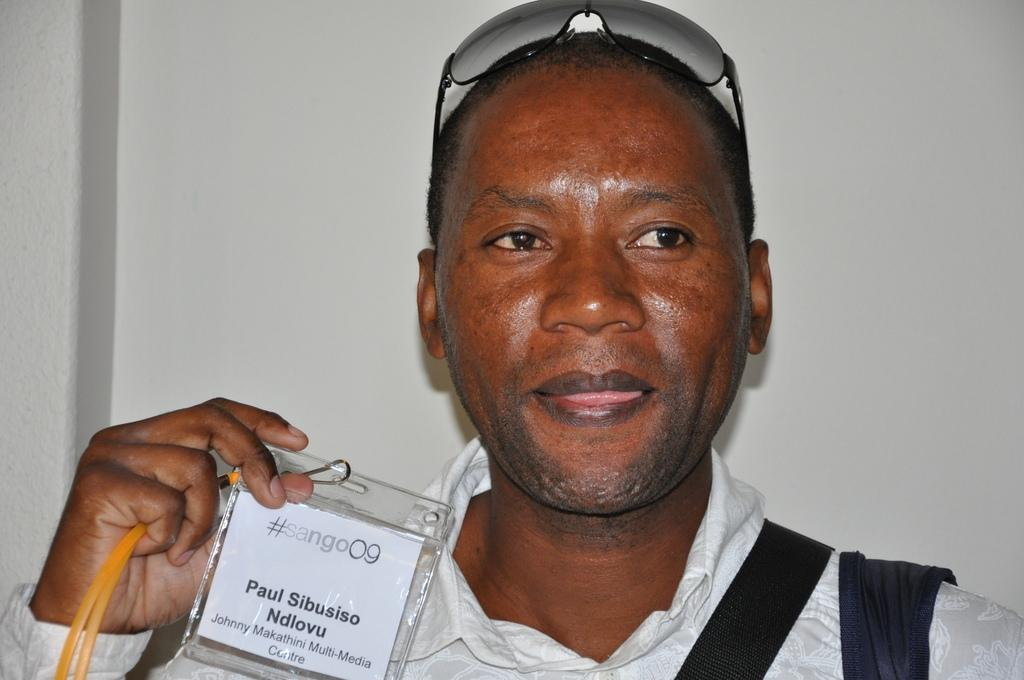Who or what is the main subject in the image? There is a person in the image. What is the person holding in the image? The person is holding an ID card. Can you describe the ID card? The ID card has text on it. What accessory is the person wearing on their head? The person is wearing glasses on their head. What can be seen in the background of the image? There is a wall visible in the image. What type of wheel is visible in the image? There is no wheel present in the image. Is the queen or judge mentioned on the ID card in the image? The ID card in the image does not mention the queen or judge. 